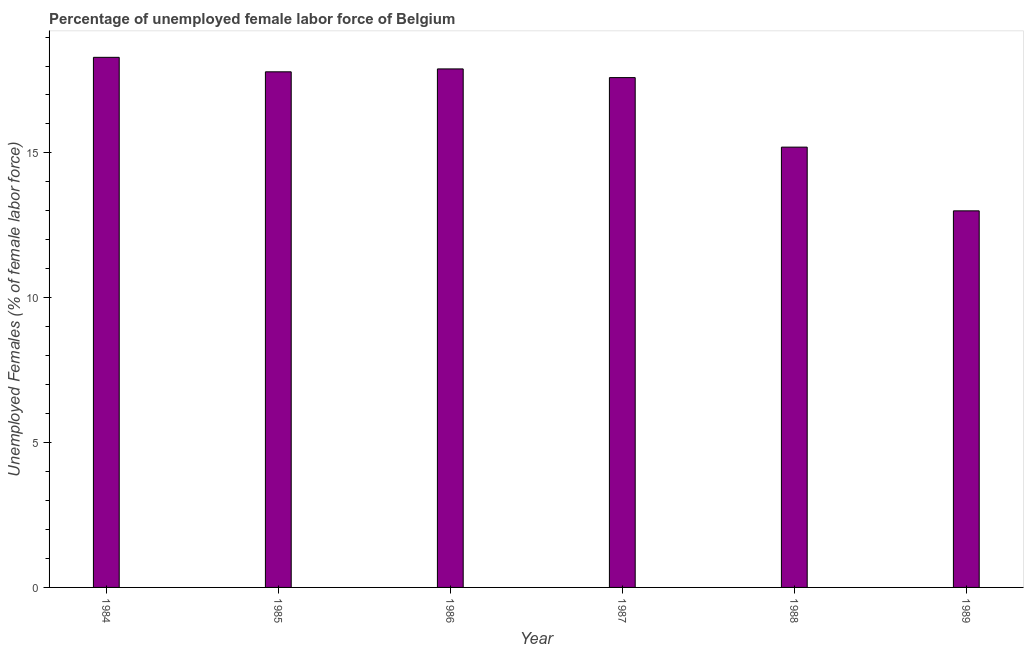Does the graph contain any zero values?
Your answer should be very brief. No. What is the title of the graph?
Your answer should be compact. Percentage of unemployed female labor force of Belgium. What is the label or title of the X-axis?
Offer a terse response. Year. What is the label or title of the Y-axis?
Provide a short and direct response. Unemployed Females (% of female labor force). What is the total unemployed female labour force in 1989?
Make the answer very short. 13. Across all years, what is the maximum total unemployed female labour force?
Ensure brevity in your answer.  18.3. In which year was the total unemployed female labour force maximum?
Provide a succinct answer. 1984. In which year was the total unemployed female labour force minimum?
Your answer should be very brief. 1989. What is the sum of the total unemployed female labour force?
Your answer should be very brief. 99.8. What is the difference between the total unemployed female labour force in 1985 and 1987?
Ensure brevity in your answer.  0.2. What is the average total unemployed female labour force per year?
Your response must be concise. 16.63. What is the median total unemployed female labour force?
Your response must be concise. 17.7. In how many years, is the total unemployed female labour force greater than 12 %?
Make the answer very short. 6. Do a majority of the years between 1986 and 1989 (inclusive) have total unemployed female labour force greater than 11 %?
Keep it short and to the point. Yes. What is the ratio of the total unemployed female labour force in 1985 to that in 1989?
Offer a very short reply. 1.37. Is the total unemployed female labour force in 1985 less than that in 1988?
Ensure brevity in your answer.  No. Is the difference between the total unemployed female labour force in 1985 and 1988 greater than the difference between any two years?
Make the answer very short. No. Is the sum of the total unemployed female labour force in 1987 and 1989 greater than the maximum total unemployed female labour force across all years?
Provide a succinct answer. Yes. What is the difference between two consecutive major ticks on the Y-axis?
Provide a succinct answer. 5. What is the Unemployed Females (% of female labor force) of 1984?
Your answer should be very brief. 18.3. What is the Unemployed Females (% of female labor force) in 1985?
Offer a very short reply. 17.8. What is the Unemployed Females (% of female labor force) in 1986?
Your response must be concise. 17.9. What is the Unemployed Females (% of female labor force) of 1987?
Keep it short and to the point. 17.6. What is the Unemployed Females (% of female labor force) of 1988?
Provide a succinct answer. 15.2. What is the Unemployed Females (% of female labor force) in 1989?
Your response must be concise. 13. What is the difference between the Unemployed Females (% of female labor force) in 1984 and 1985?
Provide a short and direct response. 0.5. What is the difference between the Unemployed Females (% of female labor force) in 1984 and 1986?
Make the answer very short. 0.4. What is the difference between the Unemployed Females (% of female labor force) in 1984 and 1988?
Your answer should be compact. 3.1. What is the difference between the Unemployed Females (% of female labor force) in 1985 and 1986?
Your answer should be very brief. -0.1. What is the difference between the Unemployed Females (% of female labor force) in 1987 and 1988?
Give a very brief answer. 2.4. What is the ratio of the Unemployed Females (% of female labor force) in 1984 to that in 1985?
Your answer should be compact. 1.03. What is the ratio of the Unemployed Females (% of female labor force) in 1984 to that in 1986?
Give a very brief answer. 1.02. What is the ratio of the Unemployed Females (% of female labor force) in 1984 to that in 1987?
Give a very brief answer. 1.04. What is the ratio of the Unemployed Females (% of female labor force) in 1984 to that in 1988?
Make the answer very short. 1.2. What is the ratio of the Unemployed Females (% of female labor force) in 1984 to that in 1989?
Your answer should be compact. 1.41. What is the ratio of the Unemployed Females (% of female labor force) in 1985 to that in 1988?
Provide a short and direct response. 1.17. What is the ratio of the Unemployed Females (% of female labor force) in 1985 to that in 1989?
Provide a succinct answer. 1.37. What is the ratio of the Unemployed Females (% of female labor force) in 1986 to that in 1987?
Provide a succinct answer. 1.02. What is the ratio of the Unemployed Females (% of female labor force) in 1986 to that in 1988?
Make the answer very short. 1.18. What is the ratio of the Unemployed Females (% of female labor force) in 1986 to that in 1989?
Ensure brevity in your answer.  1.38. What is the ratio of the Unemployed Females (% of female labor force) in 1987 to that in 1988?
Keep it short and to the point. 1.16. What is the ratio of the Unemployed Females (% of female labor force) in 1987 to that in 1989?
Offer a very short reply. 1.35. What is the ratio of the Unemployed Females (% of female labor force) in 1988 to that in 1989?
Offer a very short reply. 1.17. 